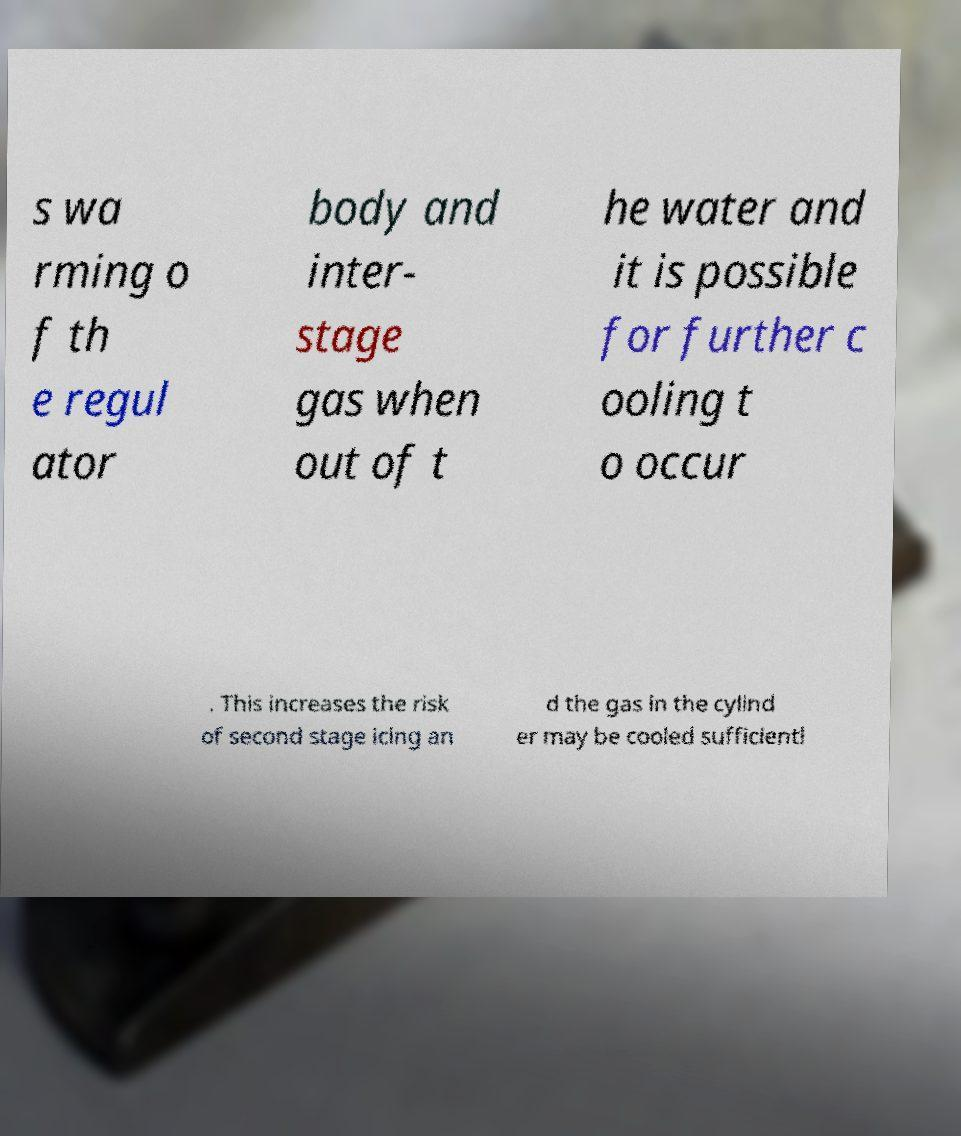Can you read and provide the text displayed in the image?This photo seems to have some interesting text. Can you extract and type it out for me? s wa rming o f th e regul ator body and inter- stage gas when out of t he water and it is possible for further c ooling t o occur . This increases the risk of second stage icing an d the gas in the cylind er may be cooled sufficientl 